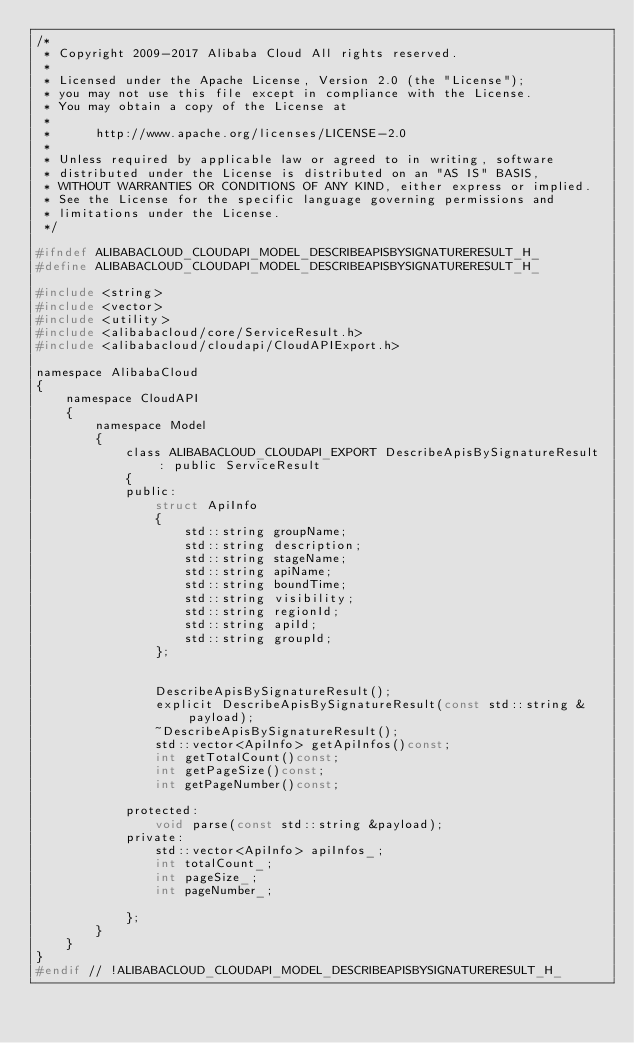Convert code to text. <code><loc_0><loc_0><loc_500><loc_500><_C_>/*
 * Copyright 2009-2017 Alibaba Cloud All rights reserved.
 * 
 * Licensed under the Apache License, Version 2.0 (the "License");
 * you may not use this file except in compliance with the License.
 * You may obtain a copy of the License at
 * 
 *      http://www.apache.org/licenses/LICENSE-2.0
 * 
 * Unless required by applicable law or agreed to in writing, software
 * distributed under the License is distributed on an "AS IS" BASIS,
 * WITHOUT WARRANTIES OR CONDITIONS OF ANY KIND, either express or implied.
 * See the License for the specific language governing permissions and
 * limitations under the License.
 */

#ifndef ALIBABACLOUD_CLOUDAPI_MODEL_DESCRIBEAPISBYSIGNATURERESULT_H_
#define ALIBABACLOUD_CLOUDAPI_MODEL_DESCRIBEAPISBYSIGNATURERESULT_H_

#include <string>
#include <vector>
#include <utility>
#include <alibabacloud/core/ServiceResult.h>
#include <alibabacloud/cloudapi/CloudAPIExport.h>

namespace AlibabaCloud
{
	namespace CloudAPI
	{
		namespace Model
		{
			class ALIBABACLOUD_CLOUDAPI_EXPORT DescribeApisBySignatureResult : public ServiceResult
			{
			public:
				struct ApiInfo
				{
					std::string groupName;
					std::string description;
					std::string stageName;
					std::string apiName;
					std::string boundTime;
					std::string visibility;
					std::string regionId;
					std::string apiId;
					std::string groupId;
				};


				DescribeApisBySignatureResult();
				explicit DescribeApisBySignatureResult(const std::string &payload);
				~DescribeApisBySignatureResult();
				std::vector<ApiInfo> getApiInfos()const;
				int getTotalCount()const;
				int getPageSize()const;
				int getPageNumber()const;

			protected:
				void parse(const std::string &payload);
			private:
				std::vector<ApiInfo> apiInfos_;
				int totalCount_;
				int pageSize_;
				int pageNumber_;

			};
		}
	}
}
#endif // !ALIBABACLOUD_CLOUDAPI_MODEL_DESCRIBEAPISBYSIGNATURERESULT_H_</code> 